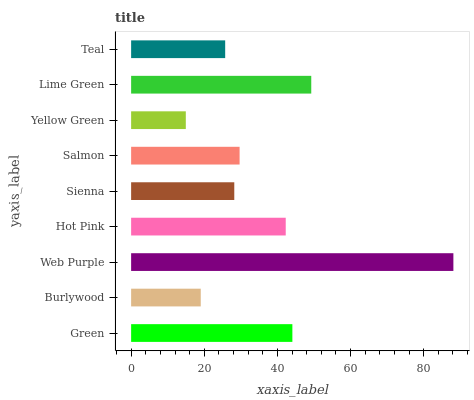Is Yellow Green the minimum?
Answer yes or no. Yes. Is Web Purple the maximum?
Answer yes or no. Yes. Is Burlywood the minimum?
Answer yes or no. No. Is Burlywood the maximum?
Answer yes or no. No. Is Green greater than Burlywood?
Answer yes or no. Yes. Is Burlywood less than Green?
Answer yes or no. Yes. Is Burlywood greater than Green?
Answer yes or no. No. Is Green less than Burlywood?
Answer yes or no. No. Is Salmon the high median?
Answer yes or no. Yes. Is Salmon the low median?
Answer yes or no. Yes. Is Teal the high median?
Answer yes or no. No. Is Yellow Green the low median?
Answer yes or no. No. 